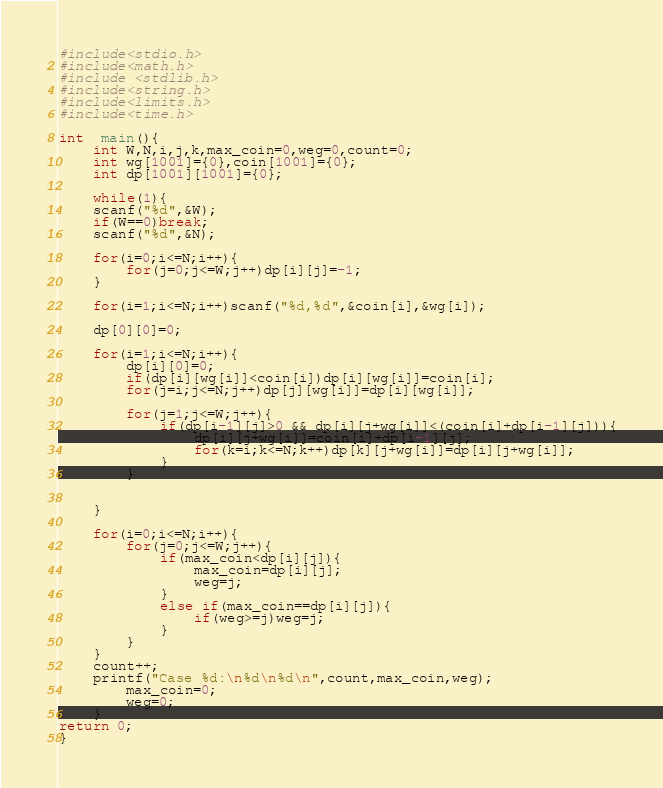Convert code to text. <code><loc_0><loc_0><loc_500><loc_500><_C_>#include<stdio.h>
#include<math.h>
#include <stdlib.h>
#include<string.h>
#include<limits.h>
#include<time.h>

int  main(){
	int W,N,i,j,k,max_coin=0,weg=0,count=0;
	int wg[1001]={0},coin[1001]={0};
	int dp[1001][1001]={0};
	
	while(1){
	scanf("%d",&W);
	if(W==0)break;
	scanf("%d",&N);
	
	for(i=0;i<=N;i++){
		for(j=0;j<=W;j++)dp[i][j]=-1;
	}
	
	for(i=1;i<=N;i++)scanf("%d,%d",&coin[i],&wg[i]);
	
	dp[0][0]=0;
	
	for(i=1;i<=N;i++){
		dp[i][0]=0;
		if(dp[i][wg[i]]<coin[i])dp[i][wg[i]]=coin[i];
		for(j=i;j<=N;j++)dp[j][wg[i]]=dp[i][wg[i]];
		
		for(j=1;j<=W;j++){
			if(dp[i-1][j]>0 && dp[i][j+wg[i]]<(coin[i]+dp[i-1][j])){
				dp[i][j+wg[i]]=coin[i]+dp[i-1][j];
				for(k=i;k<=N;k++)dp[k][j+wg[i]]=dp[i][j+wg[i]];
			}
		}

	
	}
	
	for(i=0;i<=N;i++){
		for(j=0;j<=W;j++){
			if(max_coin<dp[i][j]){
				max_coin=dp[i][j];
				weg=j;
			}
			else if(max_coin==dp[i][j]){
				if(weg>=j)weg=j;
			}
		}
	}
	count++;
	printf("Case %d:\n%d\n%d\n",count,max_coin,weg);
		max_coin=0;
		weg=0;
	}
return 0;
}</code> 